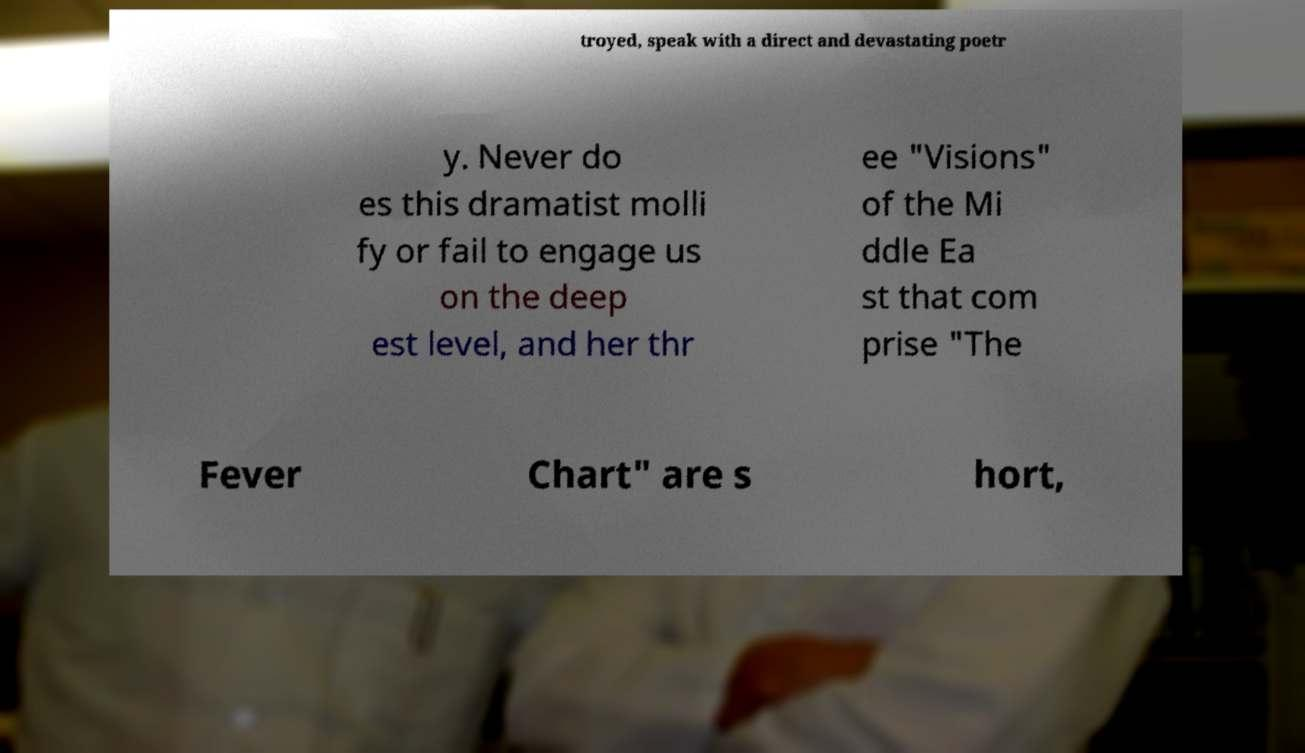What messages or text are displayed in this image? I need them in a readable, typed format. troyed, speak with a direct and devastating poetr y. Never do es this dramatist molli fy or fail to engage us on the deep est level, and her thr ee "Visions" of the Mi ddle Ea st that com prise "The Fever Chart" are s hort, 